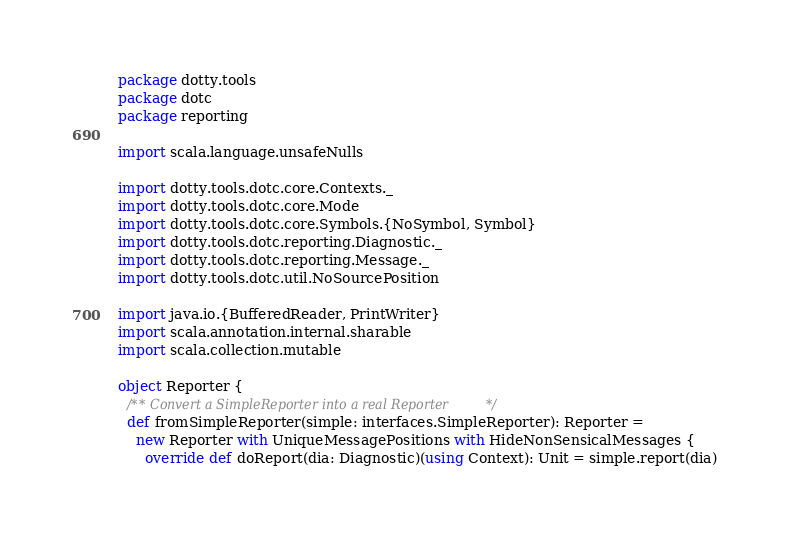Convert code to text. <code><loc_0><loc_0><loc_500><loc_500><_Scala_>package dotty.tools
package dotc
package reporting

import scala.language.unsafeNulls

import dotty.tools.dotc.core.Contexts._
import dotty.tools.dotc.core.Mode
import dotty.tools.dotc.core.Symbols.{NoSymbol, Symbol}
import dotty.tools.dotc.reporting.Diagnostic._
import dotty.tools.dotc.reporting.Message._
import dotty.tools.dotc.util.NoSourcePosition

import java.io.{BufferedReader, PrintWriter}
import scala.annotation.internal.sharable
import scala.collection.mutable

object Reporter {
  /** Convert a SimpleReporter into a real Reporter */
  def fromSimpleReporter(simple: interfaces.SimpleReporter): Reporter =
    new Reporter with UniqueMessagePositions with HideNonSensicalMessages {
      override def doReport(dia: Diagnostic)(using Context): Unit = simple.report(dia)</code> 